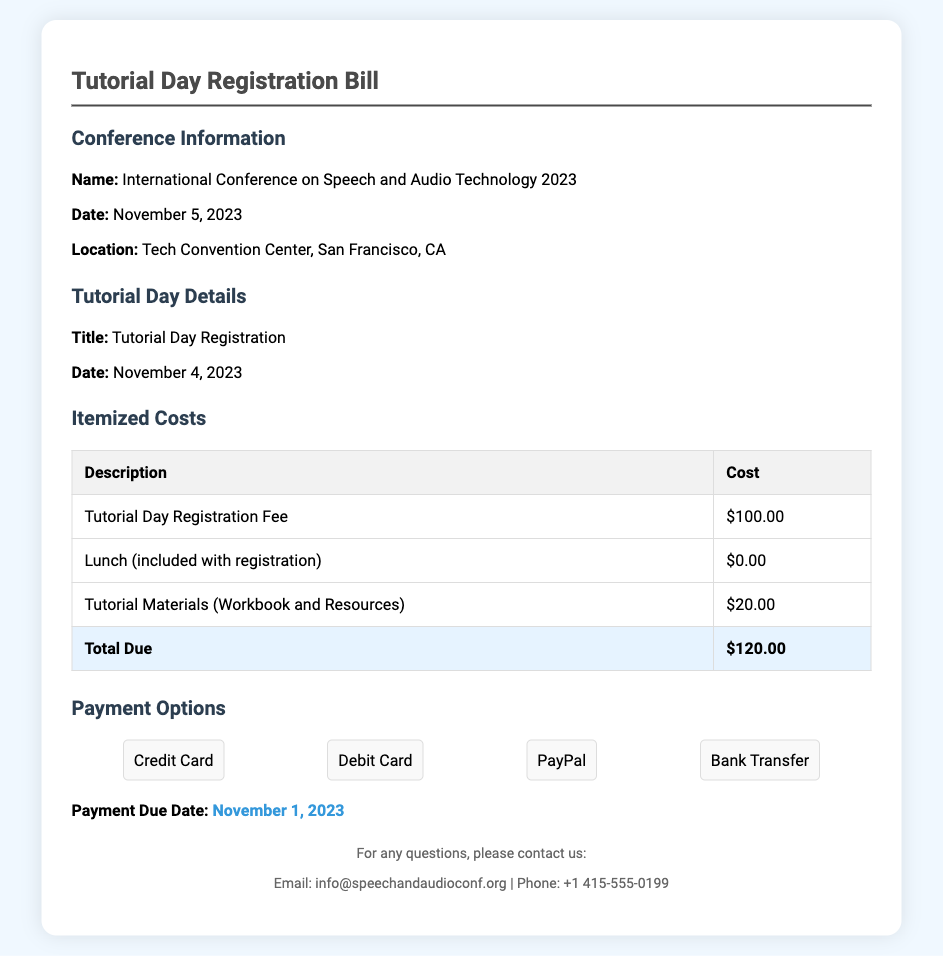What is the name of the conference? The name of the conference is stated in the document under the "Conference Information" section.
Answer: International Conference on Speech and Audio Technology 2023 What is the date of the Tutorial Day? The date of the Tutorial Day is mentioned in the "Tutorial Day Details" section of the document.
Answer: November 4, 2023 What is the total due amount? The total due amount is found in the "Itemized Costs" section, specifically in the total row.
Answer: $120.00 What payment options are available? The document lists different payment methods in the "Payment Options" section.
Answer: Credit Card, Debit Card, PayPal, Bank Transfer What is the payment due date? The payment due date is highlighted in the "Payment Options" section of the document.
Answer: November 1, 2023 How much is the Tutorial Materials cost? The cost for Tutorial Materials is listed in the "Itemized Costs" section of the bill.
Answer: $20.00 What is included with the registration fee? The inclusion is mentioned in the "Itemized Costs" section, highlighting what is covered by the registration.
Answer: Lunch (included with registration) What is the location of the conference? The location can be found in the "Conference Information" section and specifies where the event takes place.
Answer: Tech Convention Center, San Francisco, CA 